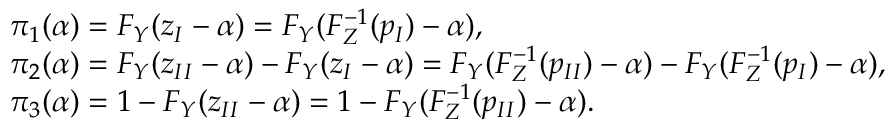<formula> <loc_0><loc_0><loc_500><loc_500>\begin{array} { r l } & { { \pi } _ { 1 } ( \alpha ) = F _ { Y } ( z _ { I } - \alpha ) = F _ { Y } ( F _ { Z } ^ { - 1 } ( p _ { I } ) - \alpha ) , } \\ & { { \pi } _ { 2 } ( \alpha ) = F _ { Y } ( z _ { I I } - \alpha ) - F _ { Y } ( z _ { I } - \alpha ) = F _ { Y } ( F _ { Z } ^ { - 1 } ( p _ { I I } ) - \alpha ) - F _ { Y } ( F _ { Z } ^ { - 1 } ( p _ { I } ) - \alpha ) , } \\ & { { \pi } _ { 3 } ( \alpha ) = 1 - F _ { Y } ( z _ { I I } - \alpha ) = 1 - F _ { Y } ( F _ { Z } ^ { - 1 } ( p _ { I I } ) - \alpha ) . } \end{array}</formula> 